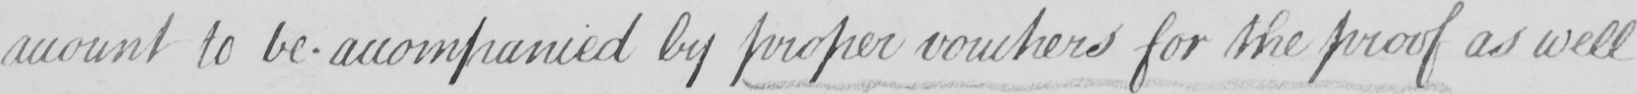What is written in this line of handwriting? amount to be accompanied by proper vouchers for the proof as well 